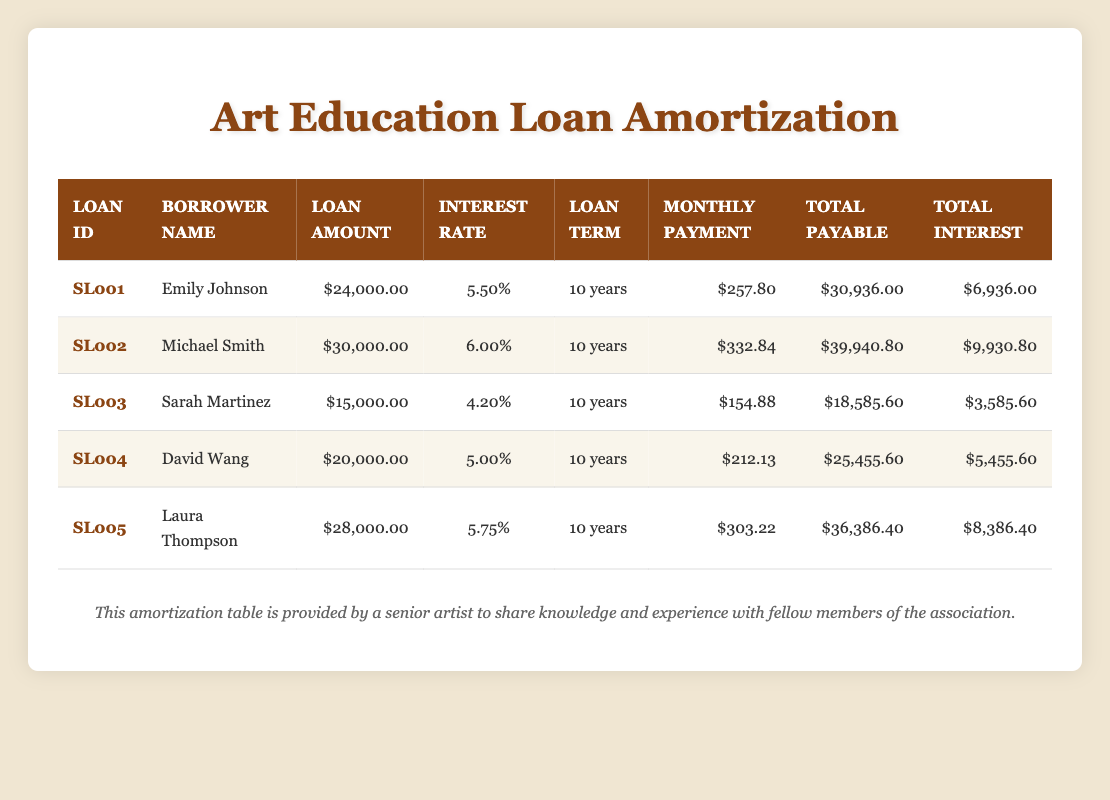What is the monthly payment for Emily Johnson's loan? Emily Johnson's loan can be found under the row with her name in the "Monthly Payment" column. The value listed there is $257.80
Answer: 257.80 What is the total interest for Michael Smith's loan? Michael Smith's loan is located in the table, and the total interest paid over the term is listed in the "Total Interest" column. The value is $9,930.80
Answer: 9,930.80 How much does Laura Thompson pay in total for her student loan? The total amount Laura Thompson will pay for her student loan is found in the "Total Payable" column for her row. The value is $36,386.40
Answer: 36,386.40 Who has the lowest interest rate among all borrowers? To find the borrower with the lowest interest rate, we compare the "Interest Rate" column for all loans. Sarah Martinez has an interest rate of 4.20%, which is the lowest when compared to others
Answer: Sarah Martinez What is the average total payable amount across all loans? To find the average total payable amount, we first sum all the total payable figures: $30,936.00 + $39,940.80 + $18,585.60 + $25,455.60 + $36,386.40 = $151,304.00. Then we divide by the number of loans (5) to find the average: $151,304.00 / 5 = $30,260.80
Answer: 30,260.80 Is David Wang's monthly payment greater than the average monthly payment of all borrowers? First, we calculate the average monthly payment: ($257.80 + $332.84 + $154.88 + $212.13 + $303.22) / 5 = $252.17. David Wang's payment is $212.13, which is less than the average
Answer: No How much more will Michael Smith pay in total compared to Emily Johnson? We calculate the difference between Michael Smith's total payable ($39,940.80) and Emily Johnson's total payable ($30,936.00): $39,940.80 - $30,936.00 = $9,004.80
Answer: 9,004.80 Which borrower has the highest loan amount? Looking at the "Loan Amount" column, we compare the values. Michael Smith's loan amount of $30,000 is the highest among all, making him the borrower with the most debt
Answer: Michael Smith What percentage of interest does Laura Thompson pay on her loan? Laura Thompson's interest rate is shown in the "Interest Rate" column, which is 5.75%. This indicates the percentage she pays on her loan. Thus, the answer is directly from that column
Answer: 5.75% 